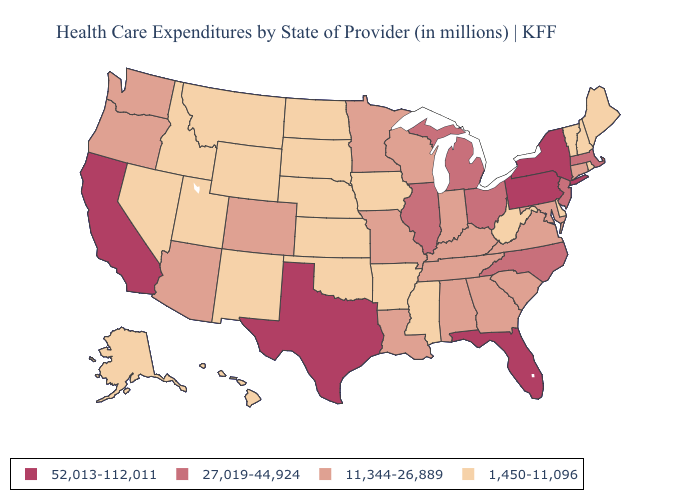Is the legend a continuous bar?
Keep it brief. No. What is the lowest value in the USA?
Keep it brief. 1,450-11,096. What is the highest value in states that border Arizona?
Short answer required. 52,013-112,011. Among the states that border New Hampshire , does Massachusetts have the highest value?
Short answer required. Yes. What is the value of Iowa?
Quick response, please. 1,450-11,096. Name the states that have a value in the range 11,344-26,889?
Concise answer only. Alabama, Arizona, Colorado, Connecticut, Georgia, Indiana, Kentucky, Louisiana, Maryland, Minnesota, Missouri, Oregon, South Carolina, Tennessee, Virginia, Washington, Wisconsin. Which states have the highest value in the USA?
Be succinct. California, Florida, New York, Pennsylvania, Texas. Name the states that have a value in the range 1,450-11,096?
Write a very short answer. Alaska, Arkansas, Delaware, Hawaii, Idaho, Iowa, Kansas, Maine, Mississippi, Montana, Nebraska, Nevada, New Hampshire, New Mexico, North Dakota, Oklahoma, Rhode Island, South Dakota, Utah, Vermont, West Virginia, Wyoming. What is the value of Maryland?
Be succinct. 11,344-26,889. Does the map have missing data?
Give a very brief answer. No. Does Connecticut have a lower value than Pennsylvania?
Answer briefly. Yes. Which states have the highest value in the USA?
Concise answer only. California, Florida, New York, Pennsylvania, Texas. Among the states that border North Dakota , which have the highest value?
Keep it brief. Minnesota. Does Alaska have the same value as Iowa?
Concise answer only. Yes. 